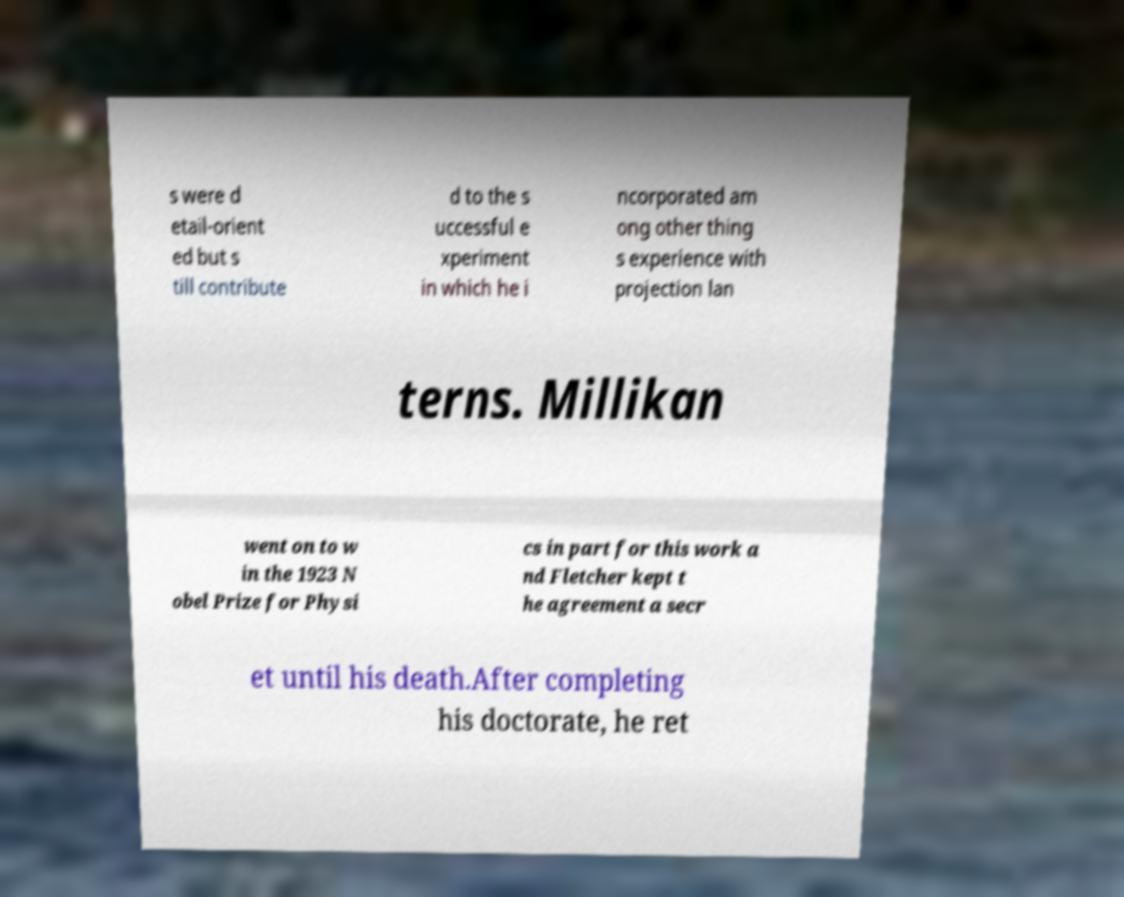There's text embedded in this image that I need extracted. Can you transcribe it verbatim? s were d etail-orient ed but s till contribute d to the s uccessful e xperiment in which he i ncorporated am ong other thing s experience with projection lan terns. Millikan went on to w in the 1923 N obel Prize for Physi cs in part for this work a nd Fletcher kept t he agreement a secr et until his death.After completing his doctorate, he ret 